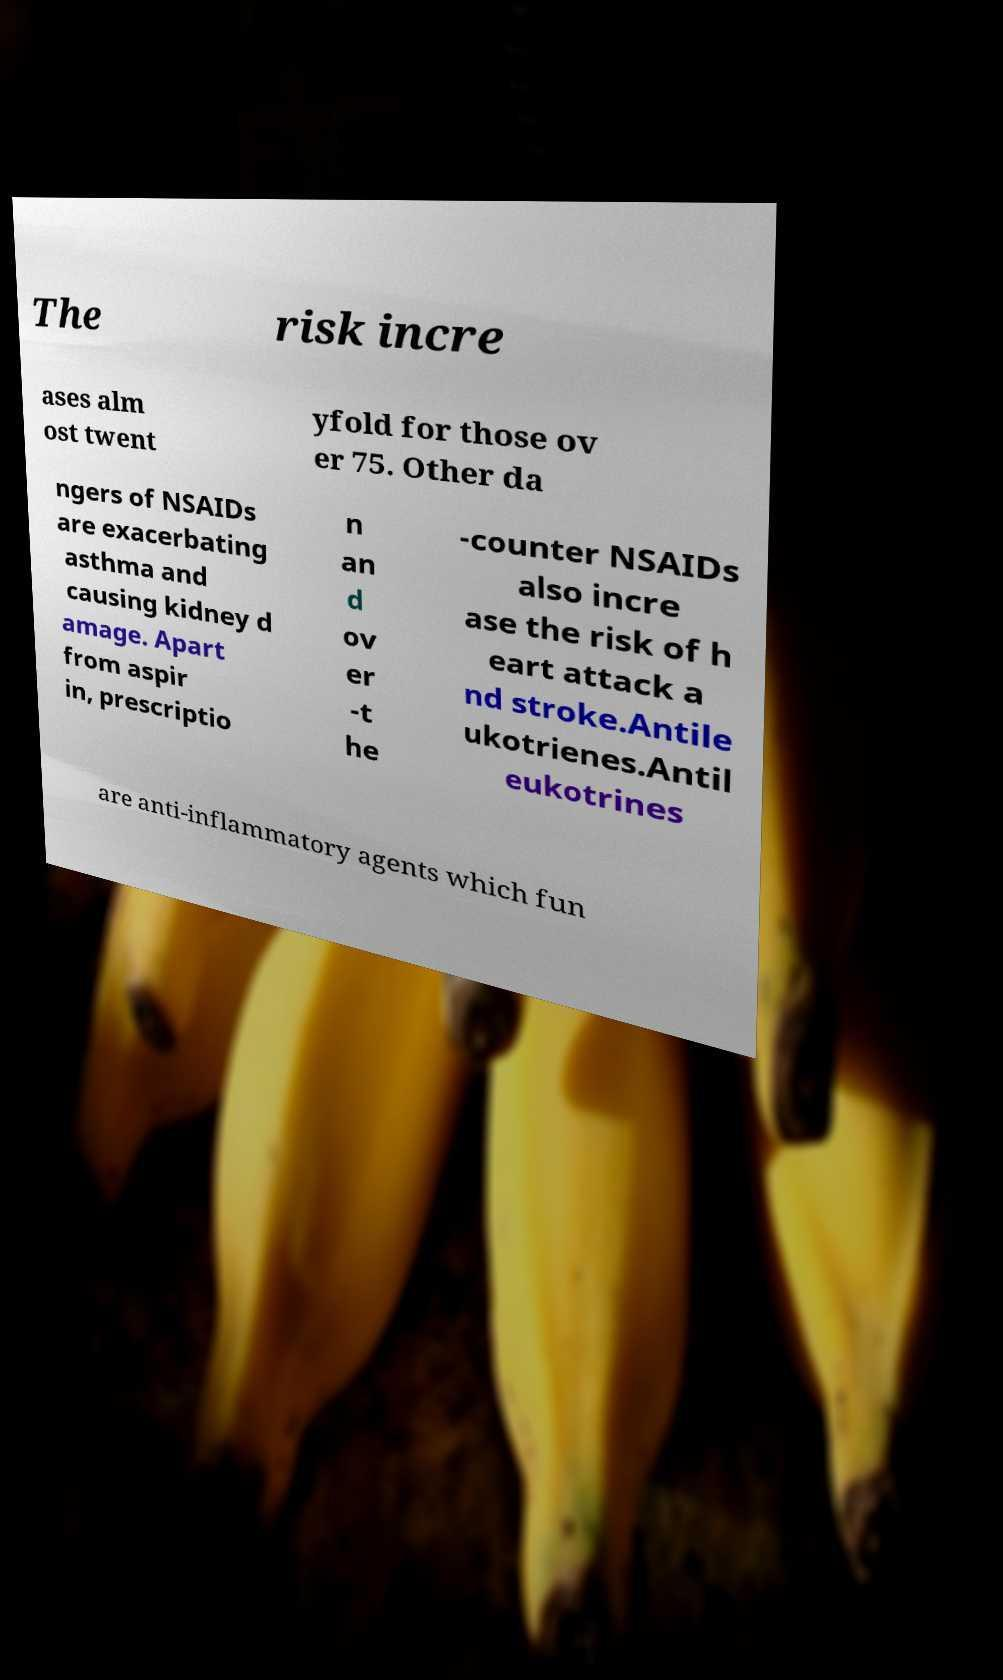Can you read and provide the text displayed in the image? This photo seems to have some interesting text. Can you extract and type it out for me? The visible text in the image discusses the health risks associated with NSAIDs. It mentions that 'The risk increases almost twentyfold for those over 75. Other dangers of NSAIDs are exacerbating asthma and causing kidney damage. Apart from aspirin, prescription and over-the-counter NSAIDs also increase the risk of heart attack and stroke. Antileukotrienes are anti-inflammatory agents which function...'. The photo implies a critical focus on drug safety, particularly for older adults. 